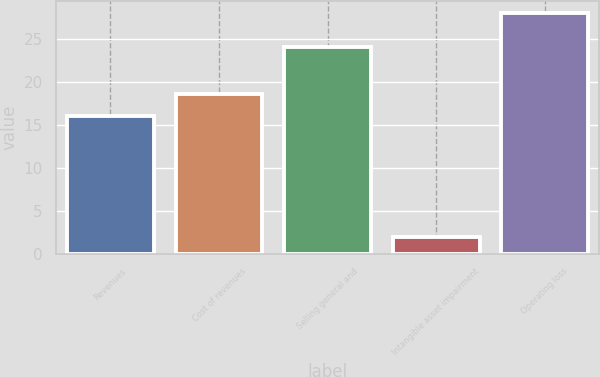Convert chart to OTSL. <chart><loc_0><loc_0><loc_500><loc_500><bar_chart><fcel>Revenues<fcel>Cost of revenues<fcel>Selling general and<fcel>Intangible asset impairment<fcel>Operating loss<nl><fcel>16<fcel>18.6<fcel>24<fcel>2<fcel>28<nl></chart> 